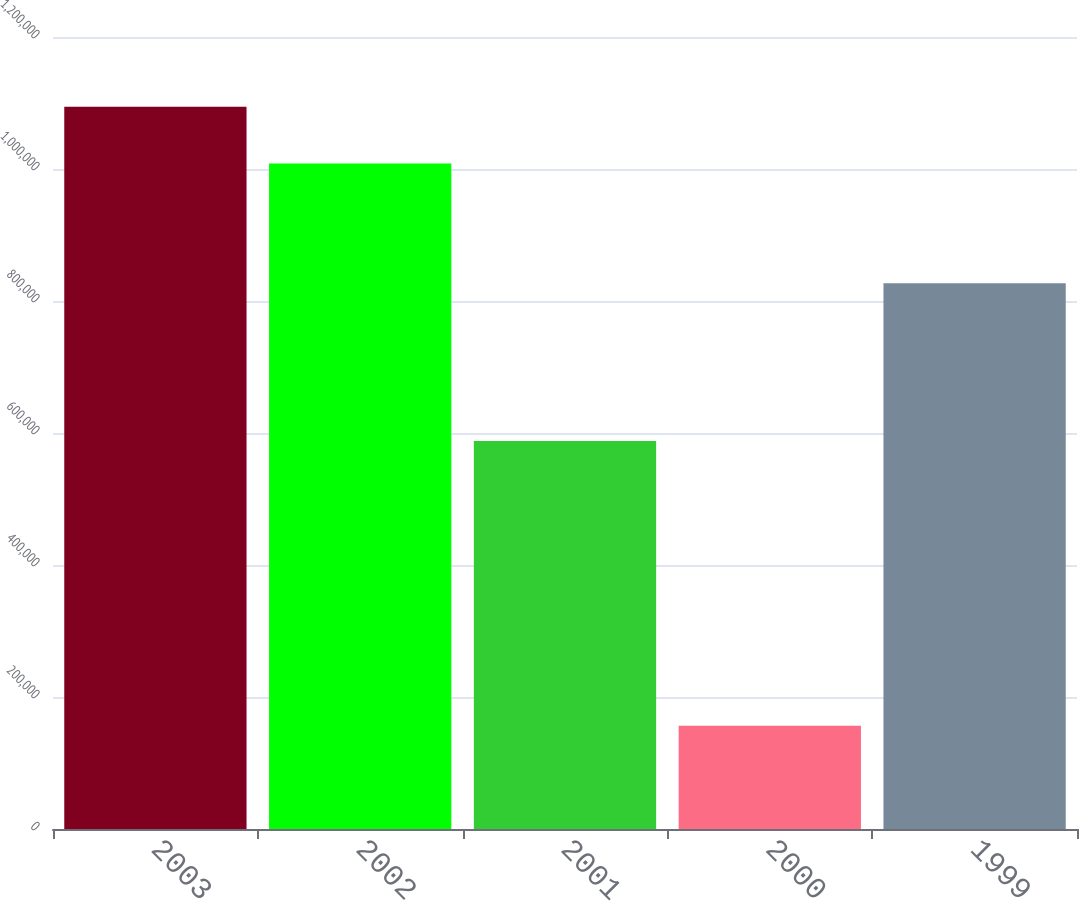<chart> <loc_0><loc_0><loc_500><loc_500><bar_chart><fcel>2003<fcel>2002<fcel>2001<fcel>2000<fcel>1999<nl><fcel>1.09425e+06<fcel>1.0085e+06<fcel>588000<fcel>156600<fcel>827050<nl></chart> 